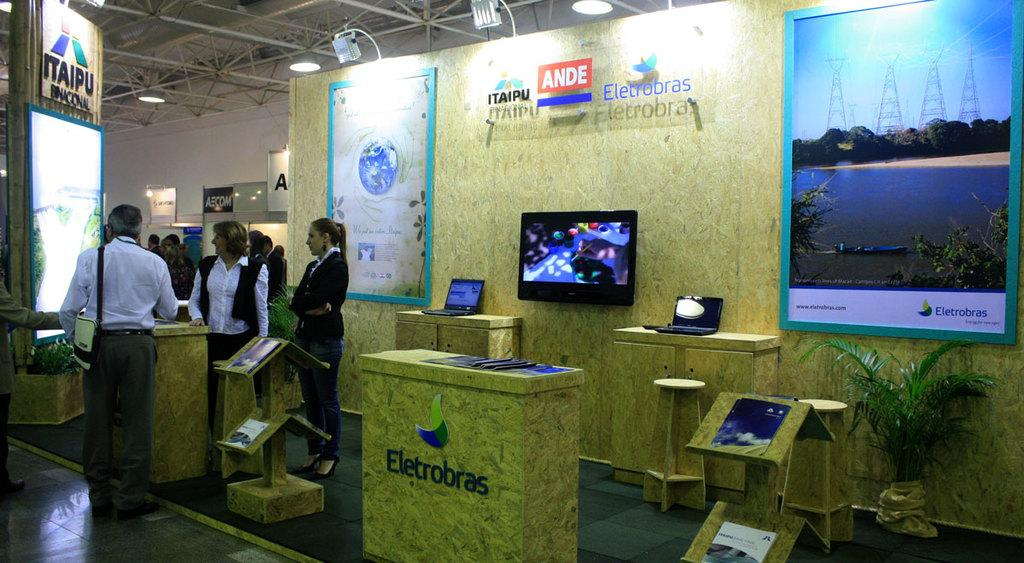<image>
Render a clear and concise summary of the photo. A waiting line in front of a display that says Electrobras. 